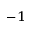<formula> <loc_0><loc_0><loc_500><loc_500>^ { - 1 }</formula> 